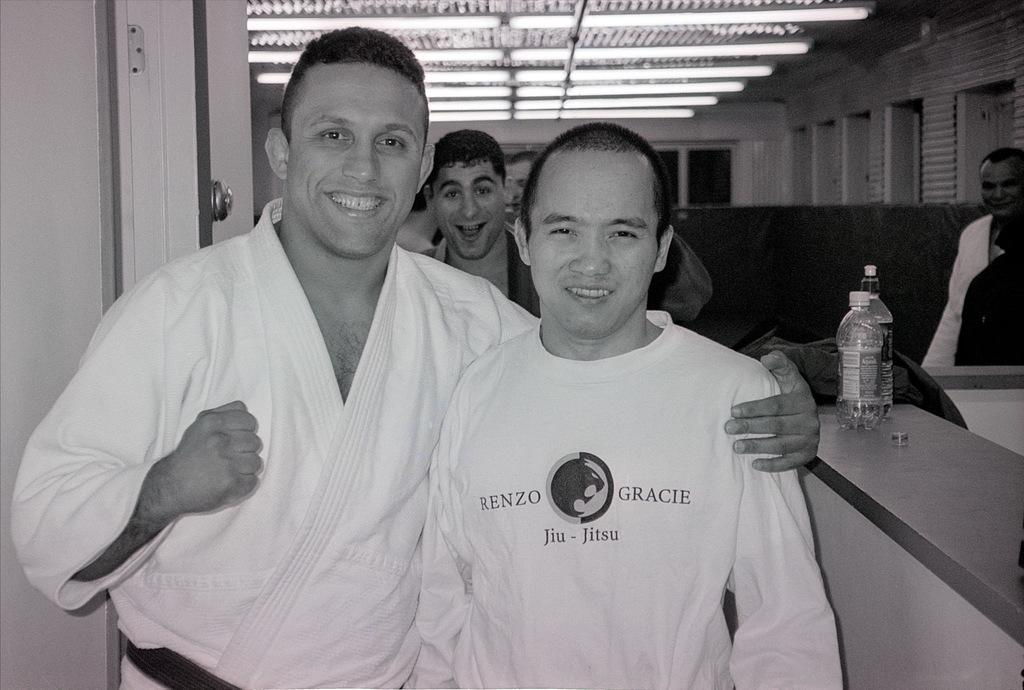What are the people in the image doing? The people in the image are standing and smiling. What is behind the people in the image? There is a wall behind the people in the image. What is on the wall? There are bottles on the wall. What is visible at the top of the image? The ceiling is visible at the top of the image. What is on the ceiling? There are lights on the ceiling. What type of leather is covering the bird in the image? There is no bird present in the image, nor is there any leather mentioned. 